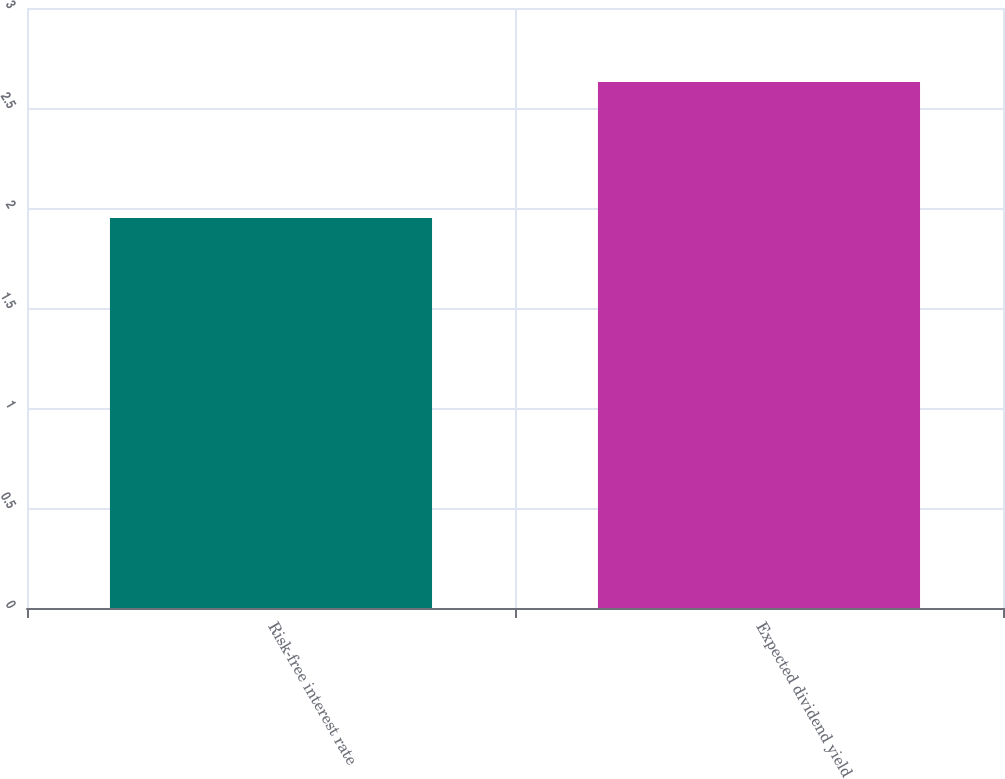<chart> <loc_0><loc_0><loc_500><loc_500><bar_chart><fcel>Risk-free interest rate<fcel>Expected dividend yield<nl><fcel>1.95<fcel>2.63<nl></chart> 